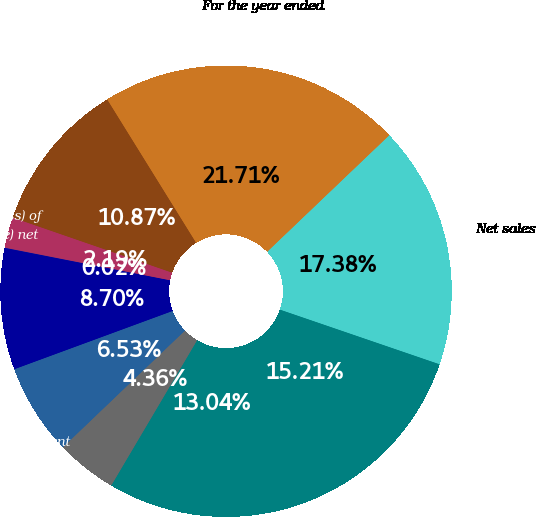Convert chart. <chart><loc_0><loc_0><loc_500><loc_500><pie_chart><fcel>For the year ended<fcel>Net sales<fcel>Cost of goods sold<fcel>Gross margin<fcel>Selling general and<fcel>Research and development<fcel>Operating income<fcel>Interest income (expense) net<fcel>Equity in net income (loss) of<fcel>Net income attributable to<nl><fcel>21.71%<fcel>17.38%<fcel>15.21%<fcel>13.04%<fcel>4.36%<fcel>6.53%<fcel>8.7%<fcel>0.02%<fcel>2.19%<fcel>10.87%<nl></chart> 